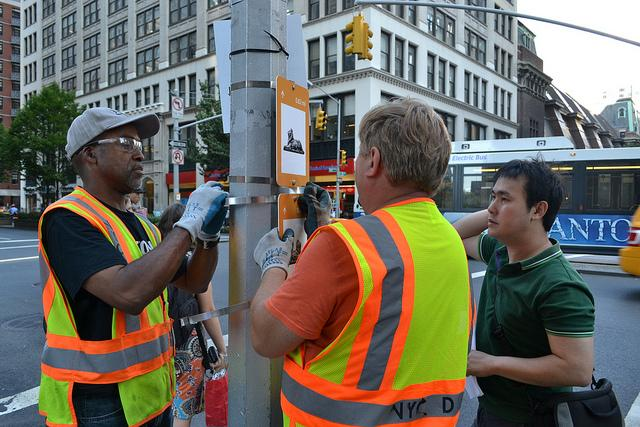What are the signs for?

Choices:
A) traffic signs
B) maps
C) selling stuff
D) missing dogs missing dogs 